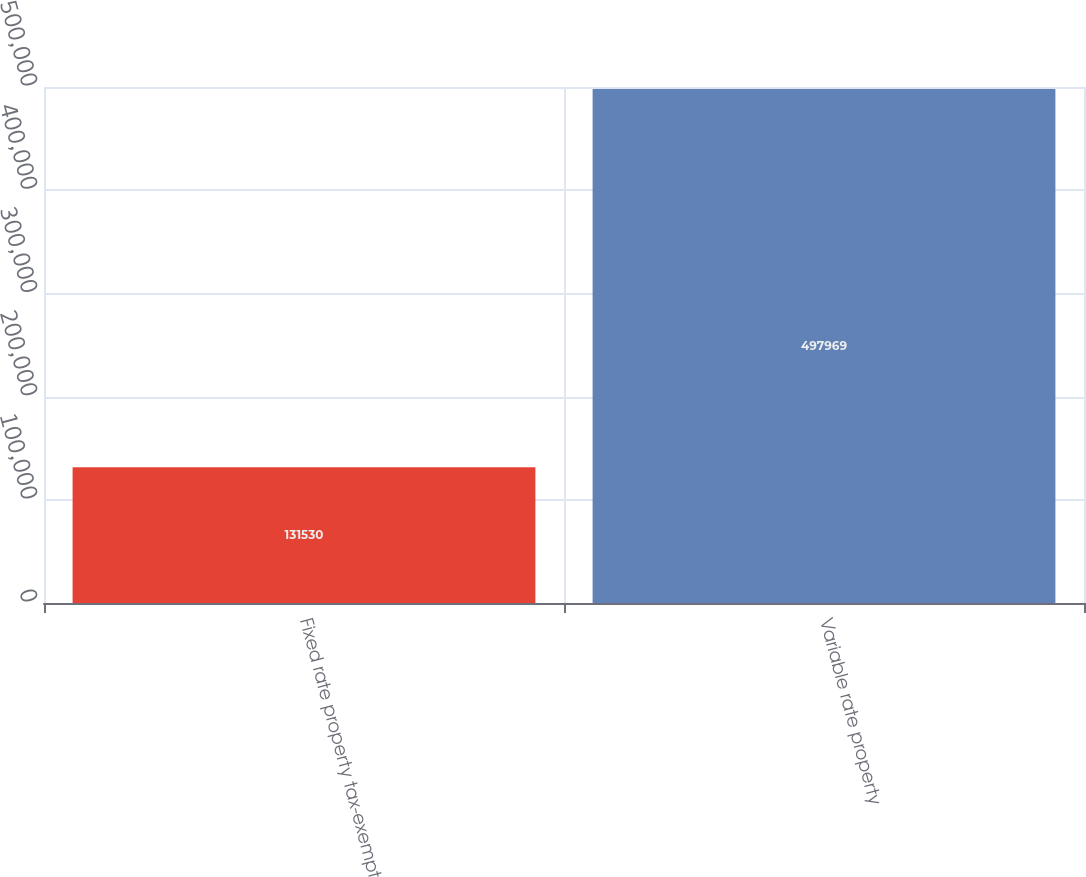<chart> <loc_0><loc_0><loc_500><loc_500><bar_chart><fcel>Fixed rate property tax-exempt<fcel>Variable rate property<nl><fcel>131530<fcel>497969<nl></chart> 